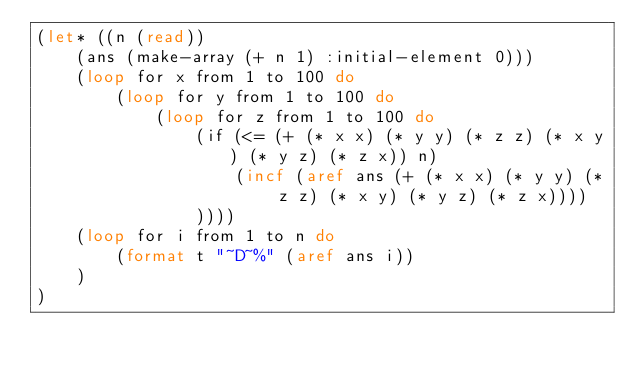Convert code to text. <code><loc_0><loc_0><loc_500><loc_500><_Lisp_>(let* ((n (read))
    (ans (make-array (+ n 1) :initial-element 0)))
    (loop for x from 1 to 100 do
        (loop for y from 1 to 100 do
            (loop for z from 1 to 100 do
                (if (<= (+ (* x x) (* y y) (* z z) (* x y) (* y z) (* z x)) n)
                    (incf (aref ans (+ (* x x) (* y y) (* z z) (* x y) (* y z) (* z x))))
                ))))
    (loop for i from 1 to n do
        (format t "~D~%" (aref ans i))
    )
)</code> 